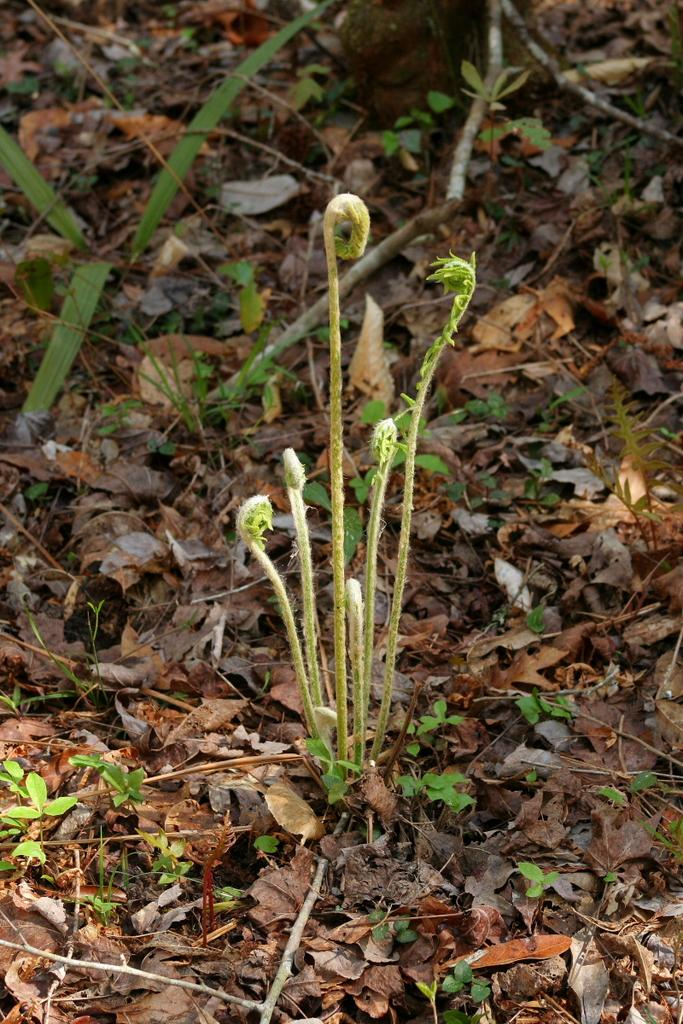What type of vegetation is present in the image? There is dry grass and a plant in the image. What object can be seen alongside the vegetation? There is a wooden stick in the image. Can you describe the ground in the image? There is grass in the image. How many brothers are playing with the cactus in the image? There are no brothers or cactus present in the image. What type of stove can be seen in the background of the image? There is no stove present in the image. 